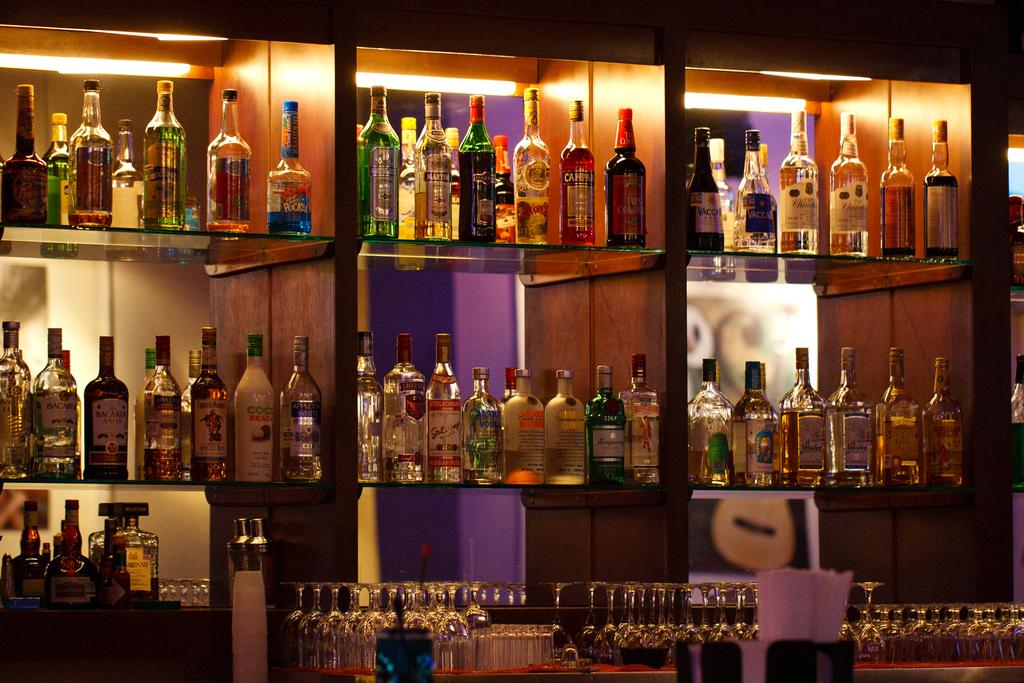What objects are visible in the image? There are different types of bottles in the image. Where are the bottles located in the image? The bottles are on shelves in the image. What type of impulse can be seen affecting the bottles in the image? There is no impulse affecting the bottles in the image; they are stationary on the shelves. What type of vessel is present in the image besides the bottles? There is no other type of vessel present in the image besides the bottles. 